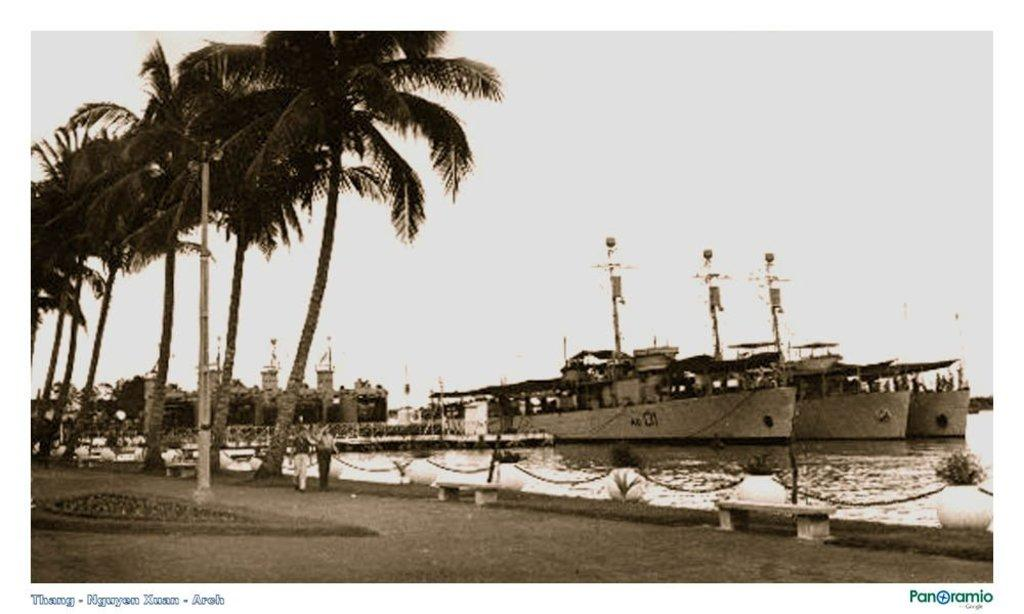Where was the image taken from? The image is taken from a website. What type of natural environment is depicted in the image? There are trees in the image, which suggests a forest or wooded area. What is visible behind the trees in the image? There is a water surface behind the trees. What can be seen on the water surface? Ships are present on the water surface. Can you see any evidence of an earthquake in the image? There is no evidence of an earthquake in the image. Is the person's father visible in the image? There is no person or father present in the image. 